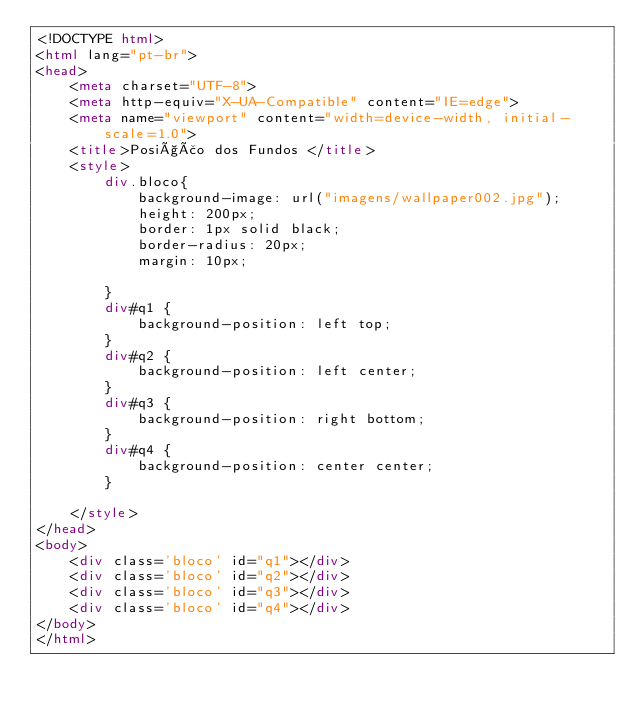<code> <loc_0><loc_0><loc_500><loc_500><_HTML_><!DOCTYPE html>
<html lang="pt-br">
<head>
    <meta charset="UTF-8">
    <meta http-equiv="X-UA-Compatible" content="IE=edge">
    <meta name="viewport" content="width=device-width, initial-scale=1.0">
    <title>Posição dos Fundos </title>
    <style>
        div.bloco{
            background-image: url("imagens/wallpaper002.jpg");
            height: 200px;
            border: 1px solid black;
            border-radius: 20px;
            margin: 10px;
            
        }
        div#q1 {
            background-position: left top;
        }
        div#q2 {
            background-position: left center;
        }
        div#q3 {
            background-position: right bottom;
        }
        div#q4 {
            background-position: center center;
        }

    </style>
</head>
<body>
    <div class='bloco' id="q1"></div>
    <div class='bloco' id="q2"></div>
    <div class='bloco' id="q3"></div>
    <div class='bloco' id="q4"></div>
</body>
</html></code> 